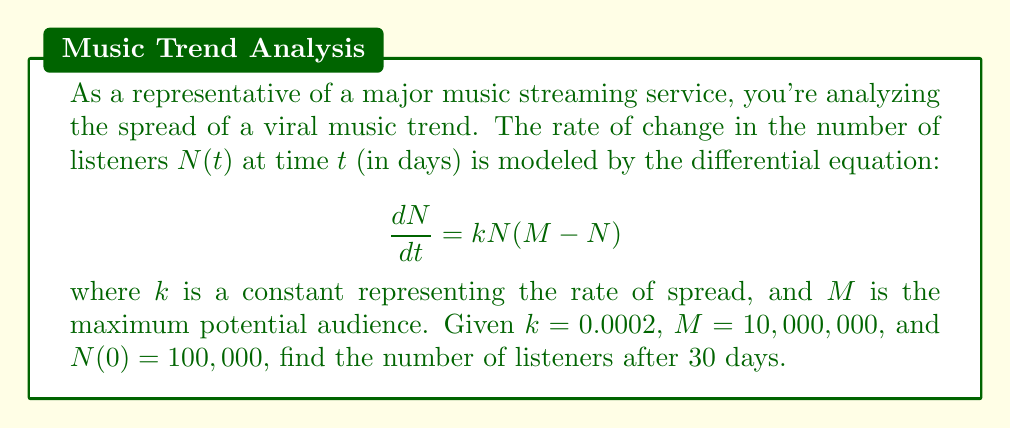Help me with this question. To solve this problem, we need to use the logistic growth model, which is a first-order differential equation.

1) The given differential equation is:

   $$\frac{dN}{dt} = kN(M-N)$$

2) This is a separable equation. We can rewrite it as:

   $$\frac{dN}{N(M-N)} = k dt$$

3) Integrating both sides:

   $$\int \frac{dN}{N(M-N)} = \int k dt$$

4) The left side can be integrated using partial fractions:

   $$\frac{1}{M} \ln|\frac{N}{M-N}| = kt + C$$

5) Solving for $N$:

   $$N = \frac{M}{1 + Ce^{-kMt}}$$

   where $C$ is a constant of integration.

6) Using the initial condition $N(0) = 100,000$:

   $$100,000 = \frac{10,000,000}{1 + C}$$

   Solving for $C$:

   $$C = 99$$

7) Therefore, our solution is:

   $$N(t) = \frac{10,000,000}{1 + 99e^{-0.0002 \cdot 10,000,000 \cdot t}}$$

8) To find $N(30)$, we substitute $t = 30$:

   $$N(30) = \frac{10,000,000}{1 + 99e^{-60,000}}$$

9) Calculating this value:

   $$N(30) \approx 9,999,999.99999$$

Therefore, after 30 days, the number of listeners is approximately 10,000,000.
Answer: $N(30) \approx 10,000,000$ listeners 